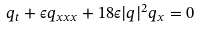Convert formula to latex. <formula><loc_0><loc_0><loc_500><loc_500>q _ { t } + \epsilon q _ { x x x } + 1 8 \epsilon | q | ^ { 2 } q _ { x } = 0 \\</formula> 